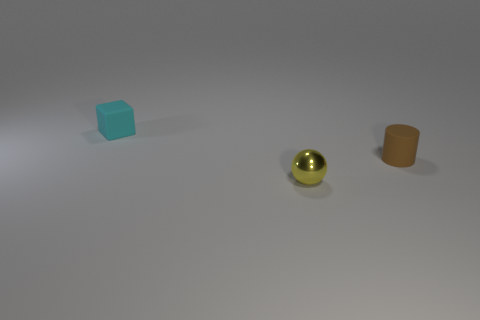Are there any other things that are the same material as the yellow ball?
Provide a short and direct response. No. What is the shape of the object that is the same material as the cylinder?
Give a very brief answer. Cube. Is the number of large blue balls greater than the number of blocks?
Provide a short and direct response. No. Do the small metal thing and the small rubber thing that is on the left side of the matte cylinder have the same shape?
Ensure brevity in your answer.  No. What is the material of the brown cylinder?
Ensure brevity in your answer.  Rubber. There is a small object in front of the tiny matte object right of the small matte thing behind the tiny cylinder; what is its color?
Provide a short and direct response. Yellow. How many blue cylinders are the same size as the yellow metallic ball?
Provide a succinct answer. 0. How many small rubber cubes are there?
Provide a succinct answer. 1. Is the small cyan object made of the same material as the small object to the right of the metal object?
Give a very brief answer. Yes. How many brown objects are tiny shiny blocks or tiny matte cylinders?
Your answer should be very brief. 1. 